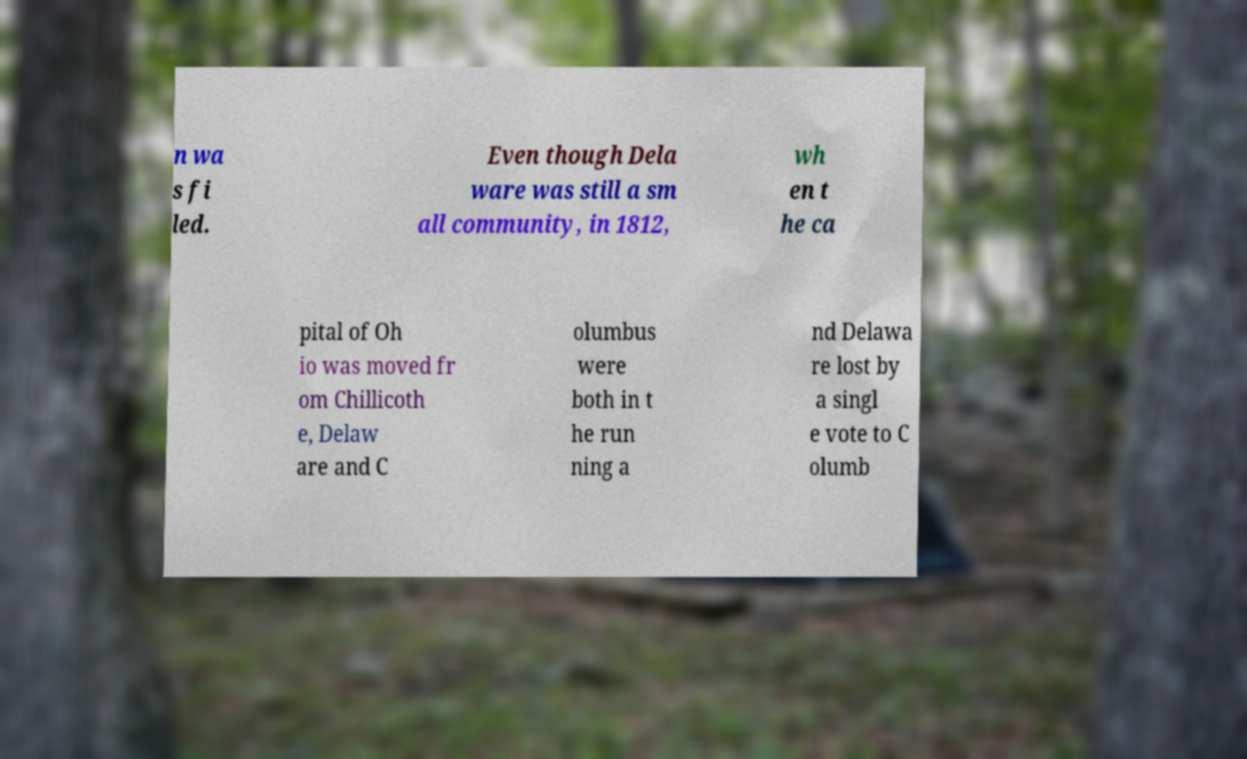Please identify and transcribe the text found in this image. n wa s fi led. Even though Dela ware was still a sm all community, in 1812, wh en t he ca pital of Oh io was moved fr om Chillicoth e, Delaw are and C olumbus were both in t he run ning a nd Delawa re lost by a singl e vote to C olumb 